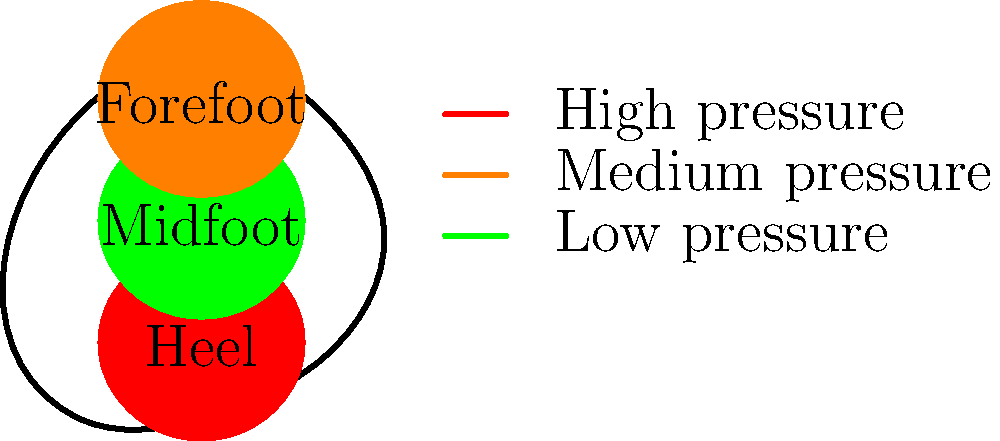Father Murphy often emphasized the importance of understanding biomechanics in everyday activities. In his memory, analyze the pressure distribution on the sole of a foot during standing. Which region typically experiences the highest pressure, and how does this change during walking? To answer this question, let's break down the pressure distribution on the sole of the foot during standing and walking:

1. Standing:
   a) The weight of the body is distributed mainly between two areas: the heel and the forefoot (including the ball of the foot and toes).
   b) The heel typically bears about 60% of the body weight, while the forefoot bears about 40%.
   c) The midfoot (arch) area usually bears minimal weight due to its elevated structure.

2. Walking:
   a) The pressure distribution changes dynamically during the gait cycle.
   b) The gait cycle can be divided into two main phases: stance phase (foot on the ground) and swing phase (foot in the air).
   c) During the stance phase:
      - Initial contact: The heel strikes the ground first, experiencing high pressure.
      - Midstance: Weight transfers through the midfoot, which experiences increased pressure compared to standing.
      - Terminal stance: The forefoot and toes bear most of the weight as the heel lifts off.

3. Pressure distribution changes:
   a) Heel: Experiences highest pressure during initial contact in walking, but consistent high pressure in standing.
   b) Midfoot: Low pressure in standing, but increased pressure during midstance of walking.
   c) Forefoot: Medium pressure in standing, but high pressure during terminal stance of walking.

Therefore, during standing, the heel typically experiences the highest pressure. During walking, the pressure distribution shifts dynamically, with the heel experiencing high pressure during initial contact and the forefoot experiencing high pressure during terminal stance.
Answer: Heel has highest pressure in standing; pressure shifts dynamically during walking. 